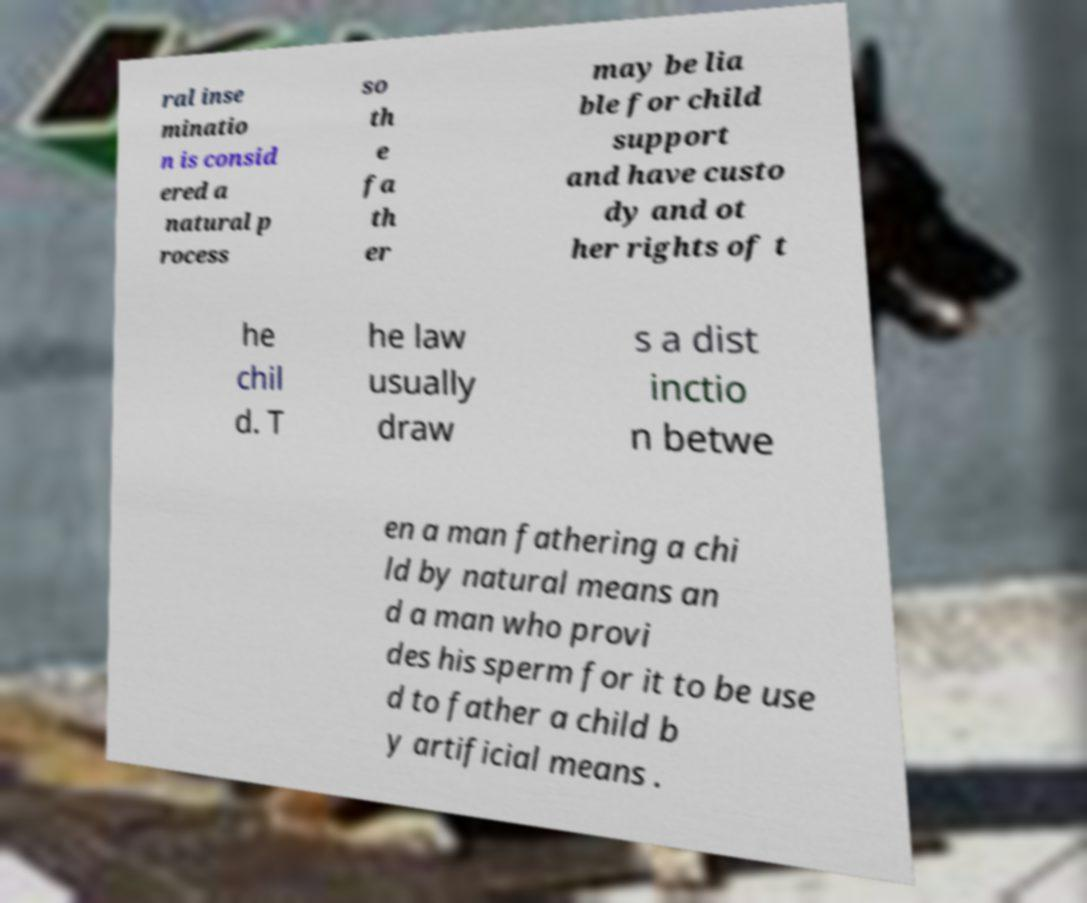Please identify and transcribe the text found in this image. ral inse minatio n is consid ered a natural p rocess so th e fa th er may be lia ble for child support and have custo dy and ot her rights of t he chil d. T he law usually draw s a dist inctio n betwe en a man fathering a chi ld by natural means an d a man who provi des his sperm for it to be use d to father a child b y artificial means . 